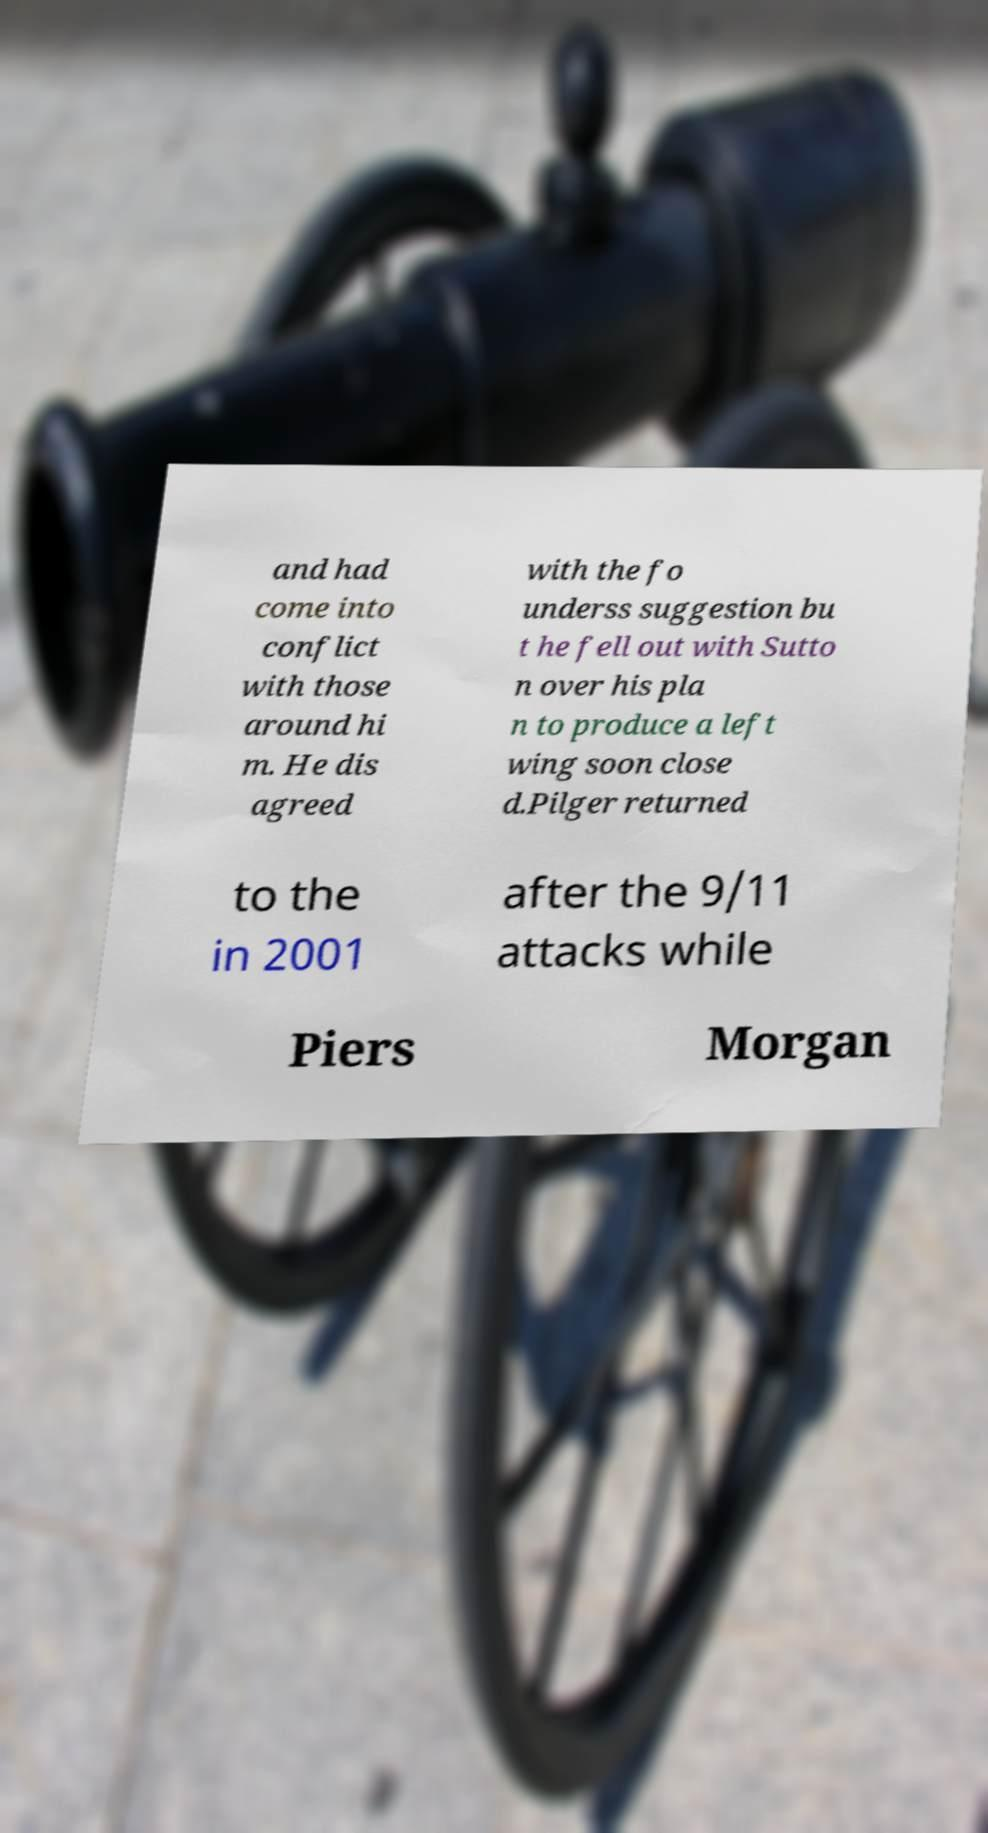Can you read and provide the text displayed in the image?This photo seems to have some interesting text. Can you extract and type it out for me? and had come into conflict with those around hi m. He dis agreed with the fo underss suggestion bu t he fell out with Sutto n over his pla n to produce a left wing soon close d.Pilger returned to the in 2001 after the 9/11 attacks while Piers Morgan 